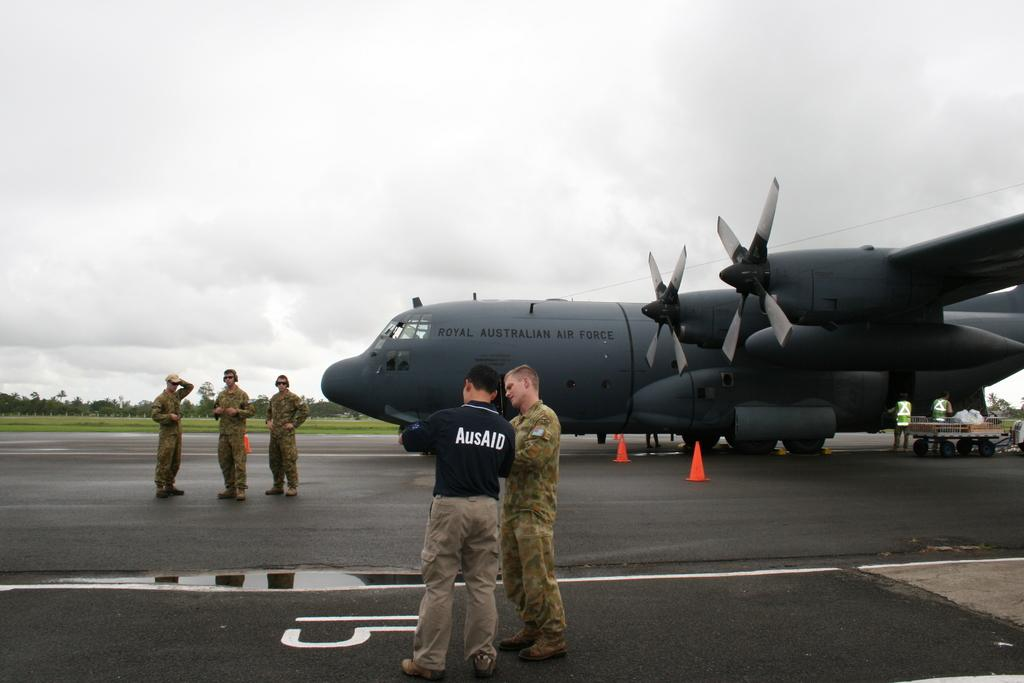<image>
Provide a brief description of the given image. A man in an AusAID shirt confers with a young pilot from the Royal Australian Air Force. 